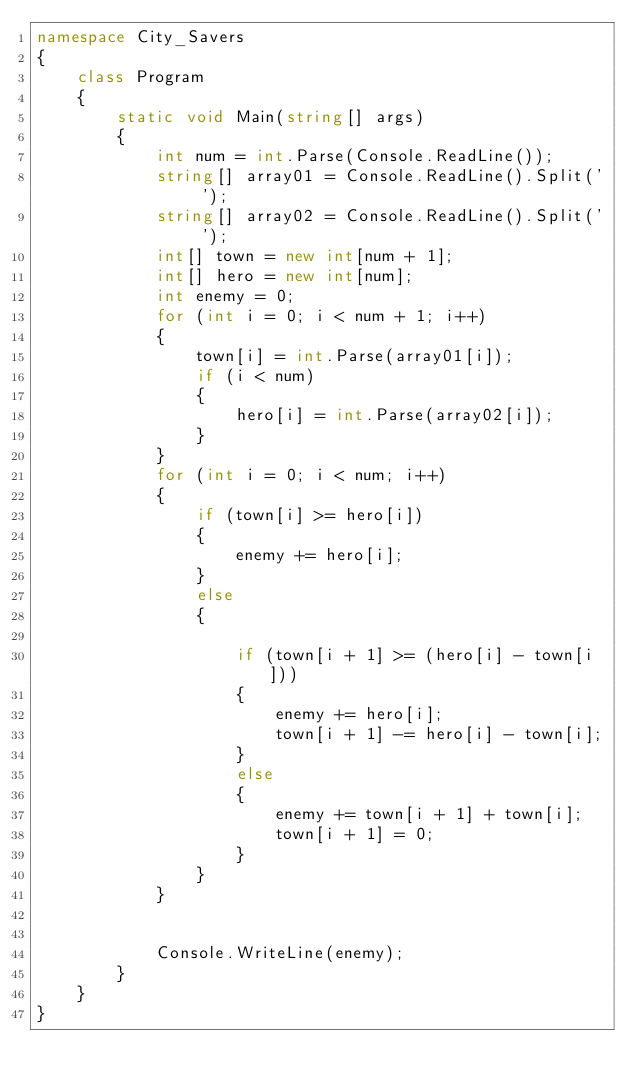Convert code to text. <code><loc_0><loc_0><loc_500><loc_500><_C#_>namespace City_Savers
{
    class Program
    {
        static void Main(string[] args)
        {
            int num = int.Parse(Console.ReadLine());
            string[] array01 = Console.ReadLine().Split(' ');
            string[] array02 = Console.ReadLine().Split(' ');
            int[] town = new int[num + 1];
            int[] hero = new int[num];
            int enemy = 0;
            for (int i = 0; i < num + 1; i++)
            {
                town[i] = int.Parse(array01[i]);
                if (i < num)
                {
                    hero[i] = int.Parse(array02[i]);
                }
            }
            for (int i = 0; i < num; i++)
            {
                if (town[i] >= hero[i])
                {
                    enemy += hero[i];
                }
                else
                {

                    if (town[i + 1] >= (hero[i] - town[i]))
                    {
                        enemy += hero[i];
                        town[i + 1] -= hero[i] - town[i];
                    }
                    else
                    {
                        enemy += town[i + 1] + town[i];
                        town[i + 1] = 0;
                    }
                }
            }


            Console.WriteLine(enemy);
        }
    }
}
</code> 